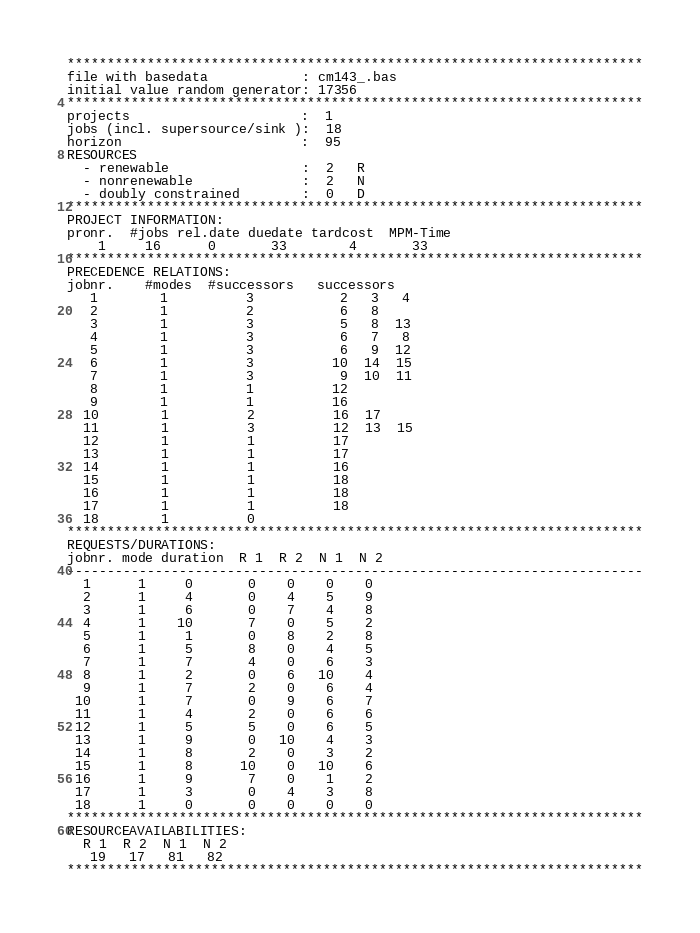<code> <loc_0><loc_0><loc_500><loc_500><_ObjectiveC_>************************************************************************
file with basedata            : cm143_.bas
initial value random generator: 17356
************************************************************************
projects                      :  1
jobs (incl. supersource/sink ):  18
horizon                       :  95
RESOURCES
  - renewable                 :  2   R
  - nonrenewable              :  2   N
  - doubly constrained        :  0   D
************************************************************************
PROJECT INFORMATION:
pronr.  #jobs rel.date duedate tardcost  MPM-Time
    1     16      0       33        4       33
************************************************************************
PRECEDENCE RELATIONS:
jobnr.    #modes  #successors   successors
   1        1          3           2   3   4
   2        1          2           6   8
   3        1          3           5   8  13
   4        1          3           6   7   8
   5        1          3           6   9  12
   6        1          3          10  14  15
   7        1          3           9  10  11
   8        1          1          12
   9        1          1          16
  10        1          2          16  17
  11        1          3          12  13  15
  12        1          1          17
  13        1          1          17
  14        1          1          16
  15        1          1          18
  16        1          1          18
  17        1          1          18
  18        1          0        
************************************************************************
REQUESTS/DURATIONS:
jobnr. mode duration  R 1  R 2  N 1  N 2
------------------------------------------------------------------------
  1      1     0       0    0    0    0
  2      1     4       0    4    5    9
  3      1     6       0    7    4    8
  4      1    10       7    0    5    2
  5      1     1       0    8    2    8
  6      1     5       8    0    4    5
  7      1     7       4    0    6    3
  8      1     2       0    6   10    4
  9      1     7       2    0    6    4
 10      1     7       0    9    6    7
 11      1     4       2    0    6    6
 12      1     5       5    0    6    5
 13      1     9       0   10    4    3
 14      1     8       2    0    3    2
 15      1     8      10    0   10    6
 16      1     9       7    0    1    2
 17      1     3       0    4    3    8
 18      1     0       0    0    0    0
************************************************************************
RESOURCEAVAILABILITIES:
  R 1  R 2  N 1  N 2
   19   17   81   82
************************************************************************
</code> 